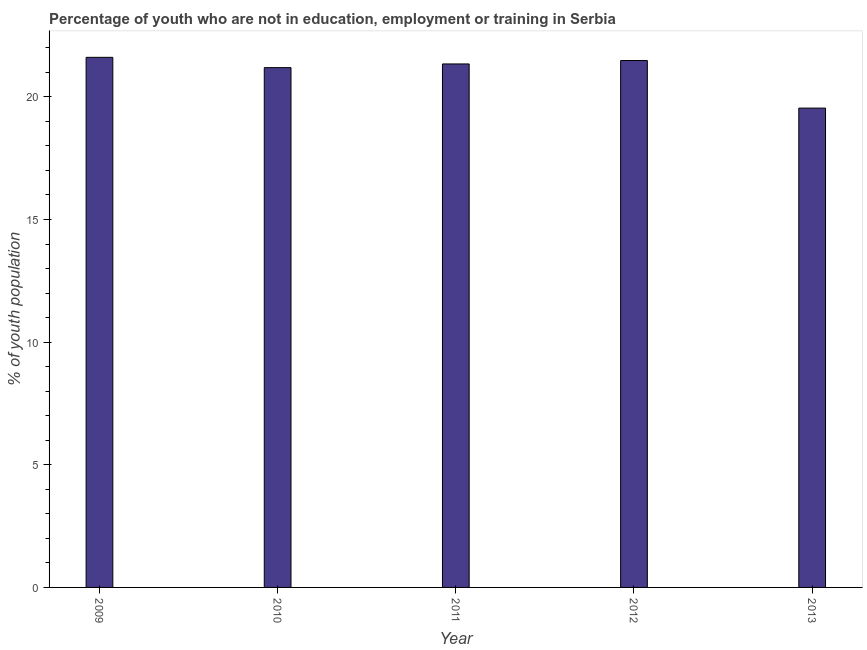Does the graph contain any zero values?
Make the answer very short. No. Does the graph contain grids?
Offer a very short reply. No. What is the title of the graph?
Give a very brief answer. Percentage of youth who are not in education, employment or training in Serbia. What is the label or title of the X-axis?
Your answer should be compact. Year. What is the label or title of the Y-axis?
Your answer should be very brief. % of youth population. What is the unemployed youth population in 2013?
Offer a terse response. 19.54. Across all years, what is the maximum unemployed youth population?
Offer a terse response. 21.61. Across all years, what is the minimum unemployed youth population?
Ensure brevity in your answer.  19.54. In which year was the unemployed youth population maximum?
Your answer should be very brief. 2009. In which year was the unemployed youth population minimum?
Offer a terse response. 2013. What is the sum of the unemployed youth population?
Make the answer very short. 105.16. What is the difference between the unemployed youth population in 2009 and 2011?
Your answer should be very brief. 0.27. What is the average unemployed youth population per year?
Provide a short and direct response. 21.03. What is the median unemployed youth population?
Your response must be concise. 21.34. Do a majority of the years between 2009 and 2013 (inclusive) have unemployed youth population greater than 6 %?
Offer a very short reply. Yes. Is the difference between the unemployed youth population in 2009 and 2013 greater than the difference between any two years?
Offer a very short reply. Yes. What is the difference between the highest and the second highest unemployed youth population?
Offer a terse response. 0.13. Is the sum of the unemployed youth population in 2010 and 2013 greater than the maximum unemployed youth population across all years?
Offer a very short reply. Yes. What is the difference between the highest and the lowest unemployed youth population?
Make the answer very short. 2.07. How many bars are there?
Offer a very short reply. 5. How many years are there in the graph?
Your answer should be compact. 5. What is the % of youth population of 2009?
Keep it short and to the point. 21.61. What is the % of youth population of 2010?
Provide a short and direct response. 21.19. What is the % of youth population in 2011?
Your answer should be compact. 21.34. What is the % of youth population in 2012?
Provide a succinct answer. 21.48. What is the % of youth population of 2013?
Offer a very short reply. 19.54. What is the difference between the % of youth population in 2009 and 2010?
Provide a short and direct response. 0.42. What is the difference between the % of youth population in 2009 and 2011?
Provide a succinct answer. 0.27. What is the difference between the % of youth population in 2009 and 2012?
Your response must be concise. 0.13. What is the difference between the % of youth population in 2009 and 2013?
Your answer should be compact. 2.07. What is the difference between the % of youth population in 2010 and 2012?
Offer a very short reply. -0.29. What is the difference between the % of youth population in 2010 and 2013?
Your answer should be compact. 1.65. What is the difference between the % of youth population in 2011 and 2012?
Give a very brief answer. -0.14. What is the difference between the % of youth population in 2012 and 2013?
Give a very brief answer. 1.94. What is the ratio of the % of youth population in 2009 to that in 2012?
Provide a succinct answer. 1.01. What is the ratio of the % of youth population in 2009 to that in 2013?
Your answer should be compact. 1.11. What is the ratio of the % of youth population in 2010 to that in 2012?
Provide a short and direct response. 0.99. What is the ratio of the % of youth population in 2010 to that in 2013?
Your answer should be compact. 1.08. What is the ratio of the % of youth population in 2011 to that in 2013?
Provide a short and direct response. 1.09. What is the ratio of the % of youth population in 2012 to that in 2013?
Your answer should be very brief. 1.1. 